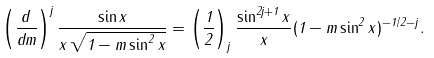<formula> <loc_0><loc_0><loc_500><loc_500>\left ( \frac { d } { d m } \right ) ^ { j } \frac { \sin x } { x \, \sqrt { 1 - m \sin ^ { 2 } x } } = \left ( \frac { 1 } { 2 } \right ) _ { j } \frac { \sin ^ { 2 j + 1 } x } { x } ( 1 - m \sin ^ { 2 } x ) ^ { - 1 / 2 - j } .</formula> 